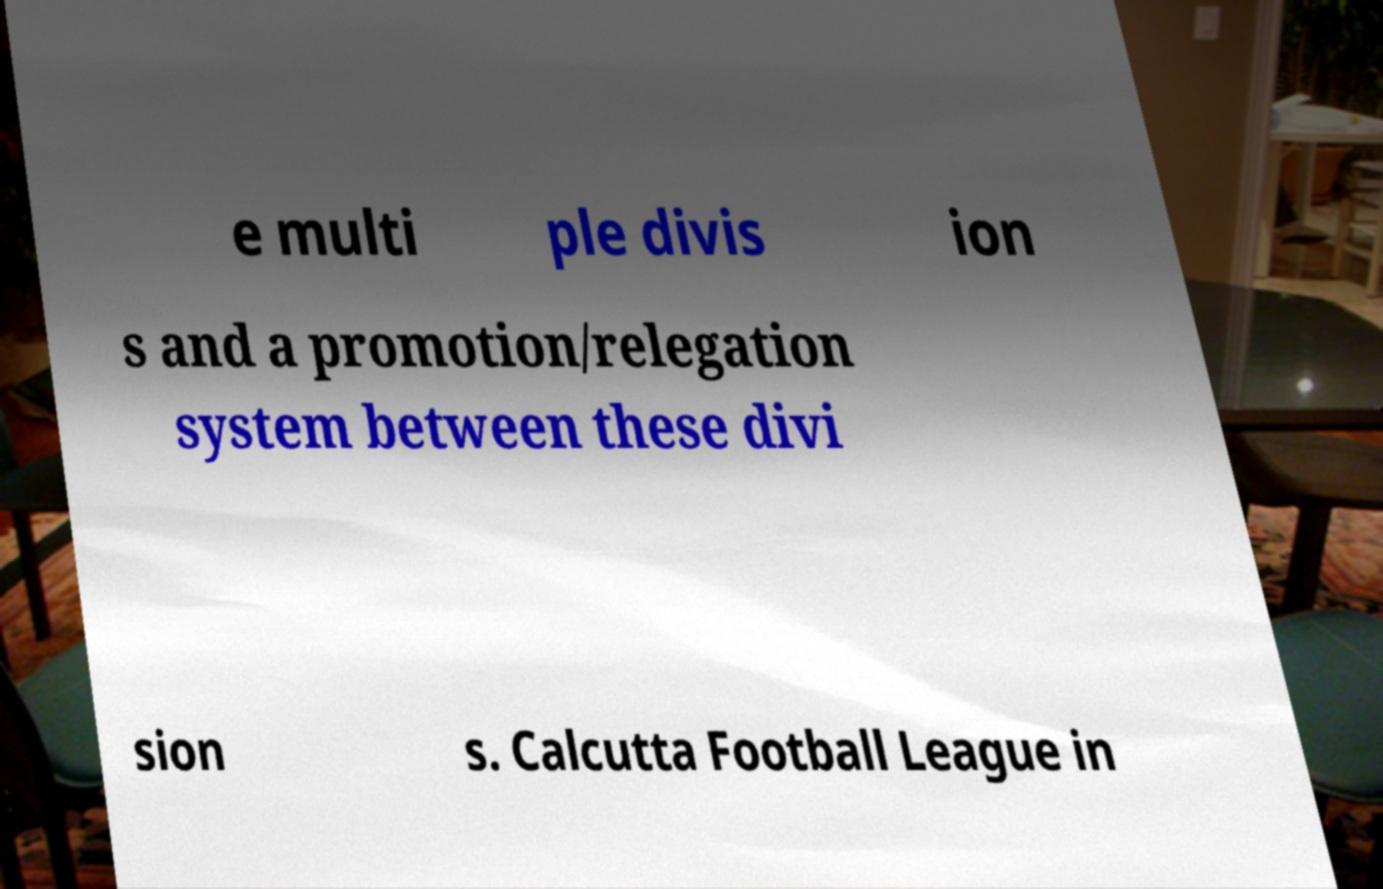What messages or text are displayed in this image? I need them in a readable, typed format. e multi ple divis ion s and a promotion/relegation system between these divi sion s. Calcutta Football League in 